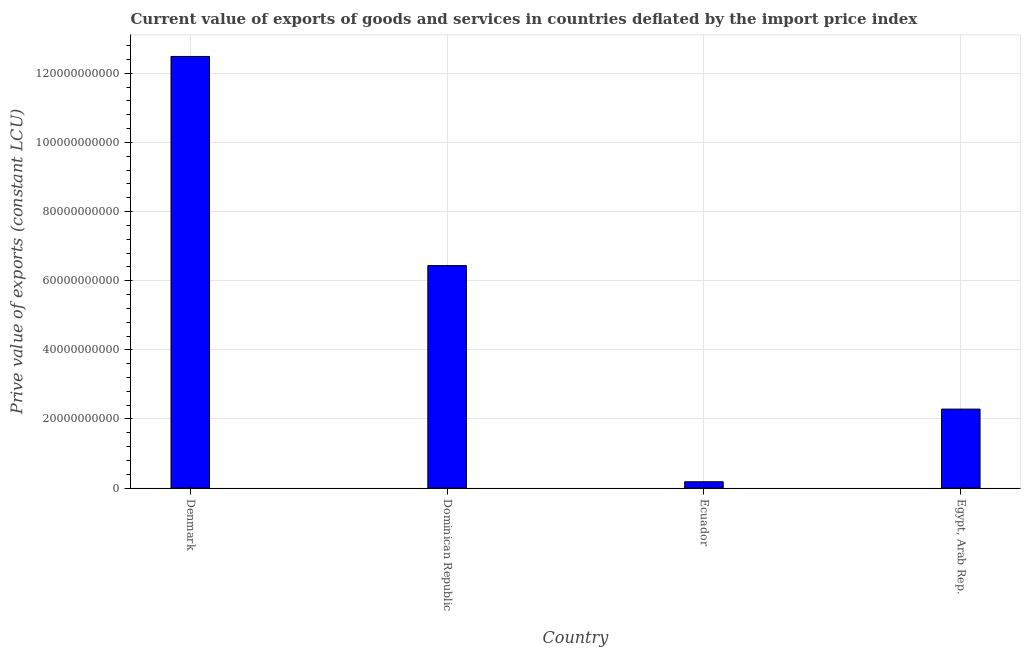Does the graph contain grids?
Keep it short and to the point. Yes. What is the title of the graph?
Make the answer very short. Current value of exports of goods and services in countries deflated by the import price index. What is the label or title of the X-axis?
Offer a very short reply. Country. What is the label or title of the Y-axis?
Ensure brevity in your answer.  Prive value of exports (constant LCU). What is the price value of exports in Egypt, Arab Rep.?
Ensure brevity in your answer.  2.29e+1. Across all countries, what is the maximum price value of exports?
Your response must be concise. 1.25e+11. Across all countries, what is the minimum price value of exports?
Keep it short and to the point. 1.83e+09. In which country was the price value of exports maximum?
Offer a very short reply. Denmark. In which country was the price value of exports minimum?
Provide a short and direct response. Ecuador. What is the sum of the price value of exports?
Offer a terse response. 2.14e+11. What is the difference between the price value of exports in Denmark and Dominican Republic?
Your response must be concise. 6.05e+1. What is the average price value of exports per country?
Provide a succinct answer. 5.35e+1. What is the median price value of exports?
Give a very brief answer. 4.36e+1. What is the ratio of the price value of exports in Denmark to that in Egypt, Arab Rep.?
Give a very brief answer. 5.46. Is the difference between the price value of exports in Denmark and Dominican Republic greater than the difference between any two countries?
Give a very brief answer. No. What is the difference between the highest and the second highest price value of exports?
Your answer should be compact. 6.05e+1. Is the sum of the price value of exports in Dominican Republic and Ecuador greater than the maximum price value of exports across all countries?
Offer a very short reply. No. What is the difference between the highest and the lowest price value of exports?
Ensure brevity in your answer.  1.23e+11. How many bars are there?
Your answer should be very brief. 4. Are all the bars in the graph horizontal?
Keep it short and to the point. No. How many countries are there in the graph?
Your answer should be very brief. 4. Are the values on the major ticks of Y-axis written in scientific E-notation?
Provide a succinct answer. No. What is the Prive value of exports (constant LCU) of Denmark?
Provide a short and direct response. 1.25e+11. What is the Prive value of exports (constant LCU) in Dominican Republic?
Offer a very short reply. 6.44e+1. What is the Prive value of exports (constant LCU) of Ecuador?
Provide a short and direct response. 1.83e+09. What is the Prive value of exports (constant LCU) of Egypt, Arab Rep.?
Offer a terse response. 2.29e+1. What is the difference between the Prive value of exports (constant LCU) in Denmark and Dominican Republic?
Offer a very short reply. 6.05e+1. What is the difference between the Prive value of exports (constant LCU) in Denmark and Ecuador?
Ensure brevity in your answer.  1.23e+11. What is the difference between the Prive value of exports (constant LCU) in Denmark and Egypt, Arab Rep.?
Provide a succinct answer. 1.02e+11. What is the difference between the Prive value of exports (constant LCU) in Dominican Republic and Ecuador?
Keep it short and to the point. 6.25e+1. What is the difference between the Prive value of exports (constant LCU) in Dominican Republic and Egypt, Arab Rep.?
Offer a very short reply. 4.15e+1. What is the difference between the Prive value of exports (constant LCU) in Ecuador and Egypt, Arab Rep.?
Offer a terse response. -2.10e+1. What is the ratio of the Prive value of exports (constant LCU) in Denmark to that in Dominican Republic?
Provide a succinct answer. 1.94. What is the ratio of the Prive value of exports (constant LCU) in Denmark to that in Ecuador?
Keep it short and to the point. 68.08. What is the ratio of the Prive value of exports (constant LCU) in Denmark to that in Egypt, Arab Rep.?
Give a very brief answer. 5.46. What is the ratio of the Prive value of exports (constant LCU) in Dominican Republic to that in Ecuador?
Keep it short and to the point. 35.09. What is the ratio of the Prive value of exports (constant LCU) in Dominican Republic to that in Egypt, Arab Rep.?
Offer a terse response. 2.82. What is the ratio of the Prive value of exports (constant LCU) in Ecuador to that in Egypt, Arab Rep.?
Your answer should be very brief. 0.08. 